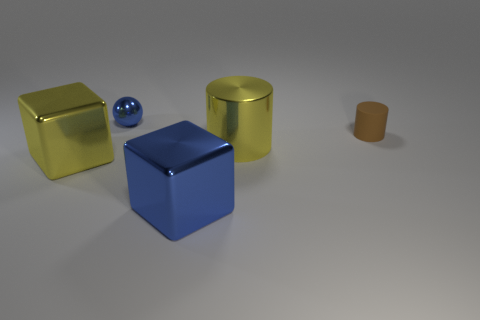There is a blue thing behind the large yellow object that is to the right of the blue object in front of the big yellow cylinder; what is it made of?
Offer a terse response. Metal. Are there the same number of brown rubber cylinders that are to the left of the large blue metallic thing and tiny brown matte cylinders?
Your answer should be very brief. No. How many things are either tiny blue metallic objects or big metallic blocks?
Your response must be concise. 3. There is a small blue thing that is the same material as the big yellow cylinder; what shape is it?
Ensure brevity in your answer.  Sphere. What size is the ball that is behind the large yellow metallic object on the left side of the yellow metallic cylinder?
Provide a short and direct response. Small. How many big objects are yellow objects or yellow shiny cylinders?
Your response must be concise. 2. What number of other objects are the same color as the matte cylinder?
Your answer should be compact. 0. Is the size of the cylinder in front of the brown thing the same as the shiny object that is behind the rubber cylinder?
Keep it short and to the point. No. Do the yellow cylinder and the large yellow object that is to the left of the metal ball have the same material?
Provide a short and direct response. Yes. Is the number of shiny balls on the right side of the small brown cylinder greater than the number of big yellow cylinders that are in front of the big yellow shiny cylinder?
Give a very brief answer. No. 